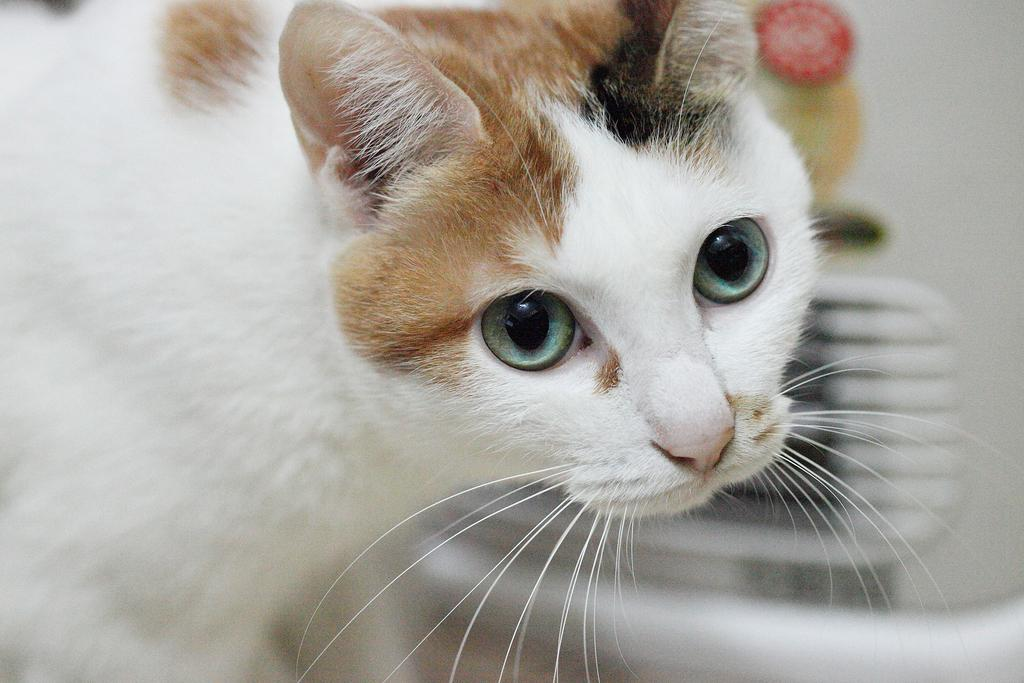What type of animal is in the image? There is a cat in the image. Can you describe the background of the image? The background of the image is blurry. What type of rake is the cat using in the image? There is no rake present in the image; it only features a cat. 